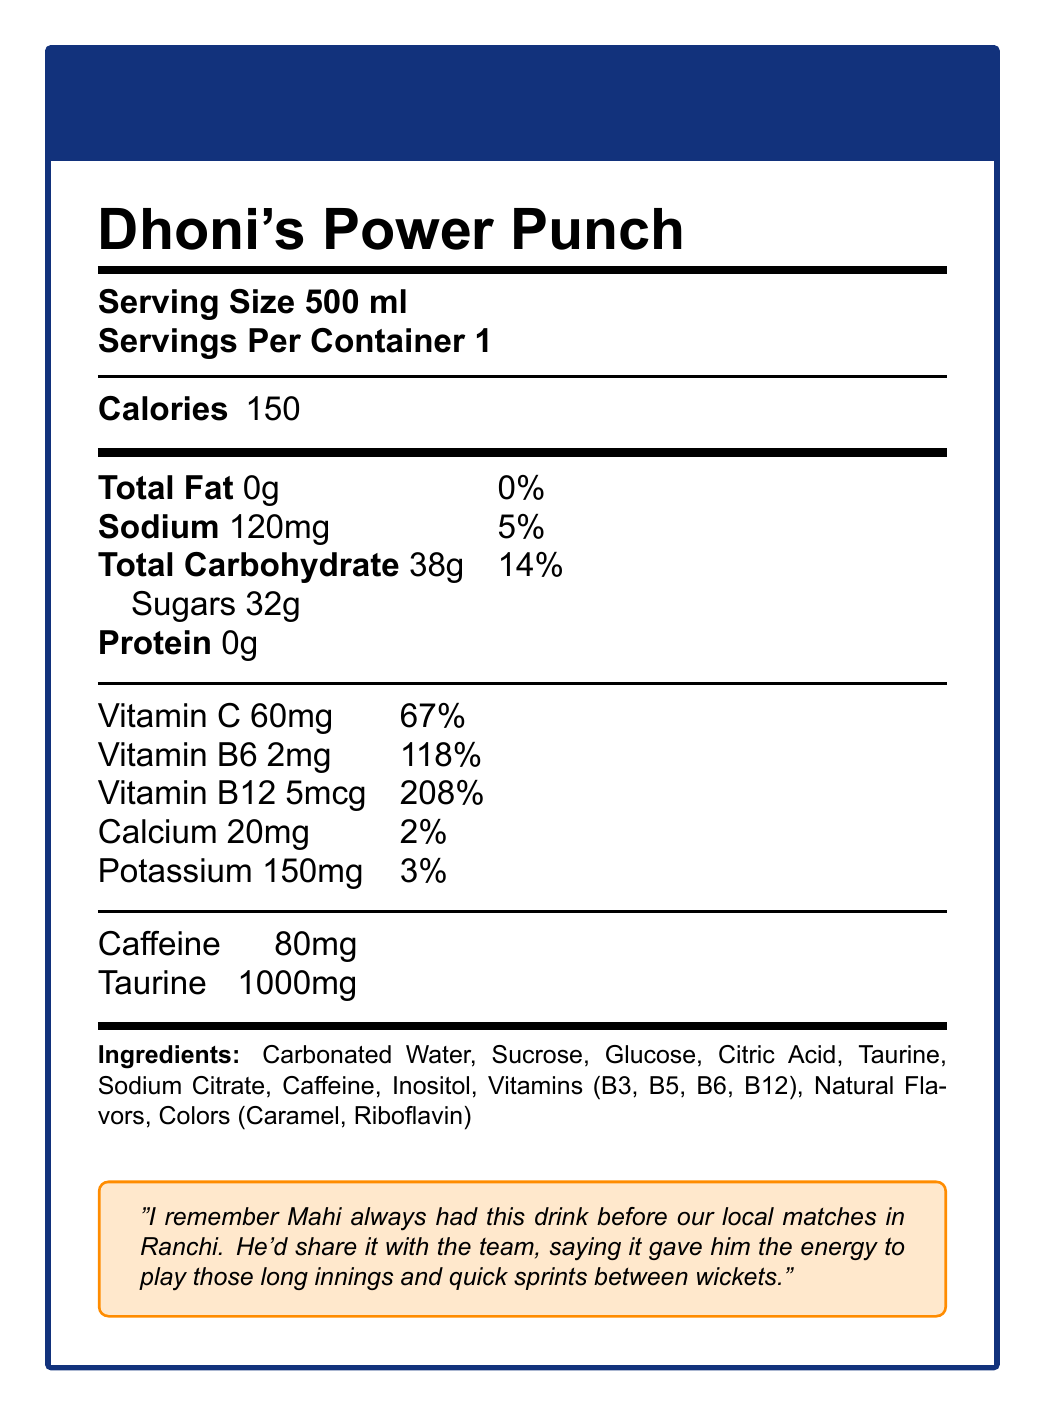what is the serving size of Dhoni's Power Punch? The document states at the top that the serving size is 500 ml.
Answer: 500 ml how many calories does one serving contain? The document lists the calorie content in a single serving as 150.
Answer: 150 how much sodium is in Dhoni's Power Punch? The sodium content is shown as 120 mg.
Answer: 120 mg which vitamin is present in the highest daily value percentage? Vitamin B12 has a daily value of 208%, which is the highest among the listed vitamins and minerals.
Answer: Vitamin B12 what is the amount of taurine in the drink? The document lists taurine content as 1000 mg.
Answer: 1000 mg which of the following ingredients is NOT present in Dhoni's Power Punch? A. Citric Acid B. Taurine C. Aspartame D. Inositol The list of ingredients does not include Aspartame.
Answer: C. Aspartame how much caffeine is in each serving? The document specifies that each serving contains 80 mg of caffeine.
Answer: 80 mg does this drink contain any protein? The document clearly states that the protein amount is 0g.
Answer: No what is the daily value percentage of Vitamin C? The document indicates that the daily value percentage of Vitamin C is 67%.
Answer: 67% what kind of flavors does the drink contain? The document lists "Natural Flavors" among the ingredients.
Answer: Natural Flavors how many servings are in one container? The document states that there is 1 serving per container.
Answer: 1 describe the main idea of the document. The document details the nutritional information for Dhoni's Power Punch, including the amount of calories, fats, carbohydrates, sugars, proteins, vitamins, and other ingredients per serving size. It also includes a personal anecdote about M.S. Dhoni's use of the drink for energy in his cricket matches.
Answer: The document provides the nutrition facts for Dhoni's Power Punch, including serving size, calories, various nutrient amounts and daily values, ingredients, and a personal note from someone who used to play cricket with M.S. Dhoni highlighting the energy provided by the drink. what is the total carbohydrate content in the drink? The document shows that the total carbohydrate content is 38g.
Answer: 38g which coloring agents are used in Dhoni's Power Punch? i. Caramel ii. Riboflavin iii. Carotenoids The document lists "Colors (Caramel, Riboflavin)" among the ingredients.
Answer: i. Caramel and ii. Riboflavin is sucrose an ingredient in the drink? The document lists sucrose as one of the ingredients.
Answer: Yes how much potassium does the drink contain? The document specifies that the potassium content is 150 mg.
Answer: 150 mg what is the daily value percentage for calcium in this drink? The document indicates that the daily value percentage for calcium is 2%.
Answer: 2% can you determine the exact flavor of the drink from the document? The document specifies "Natural Flavors" but does not provide details about the exact flavor.
Answer: Cannot be determined 